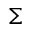<formula> <loc_0><loc_0><loc_500><loc_500>\Sigma</formula> 